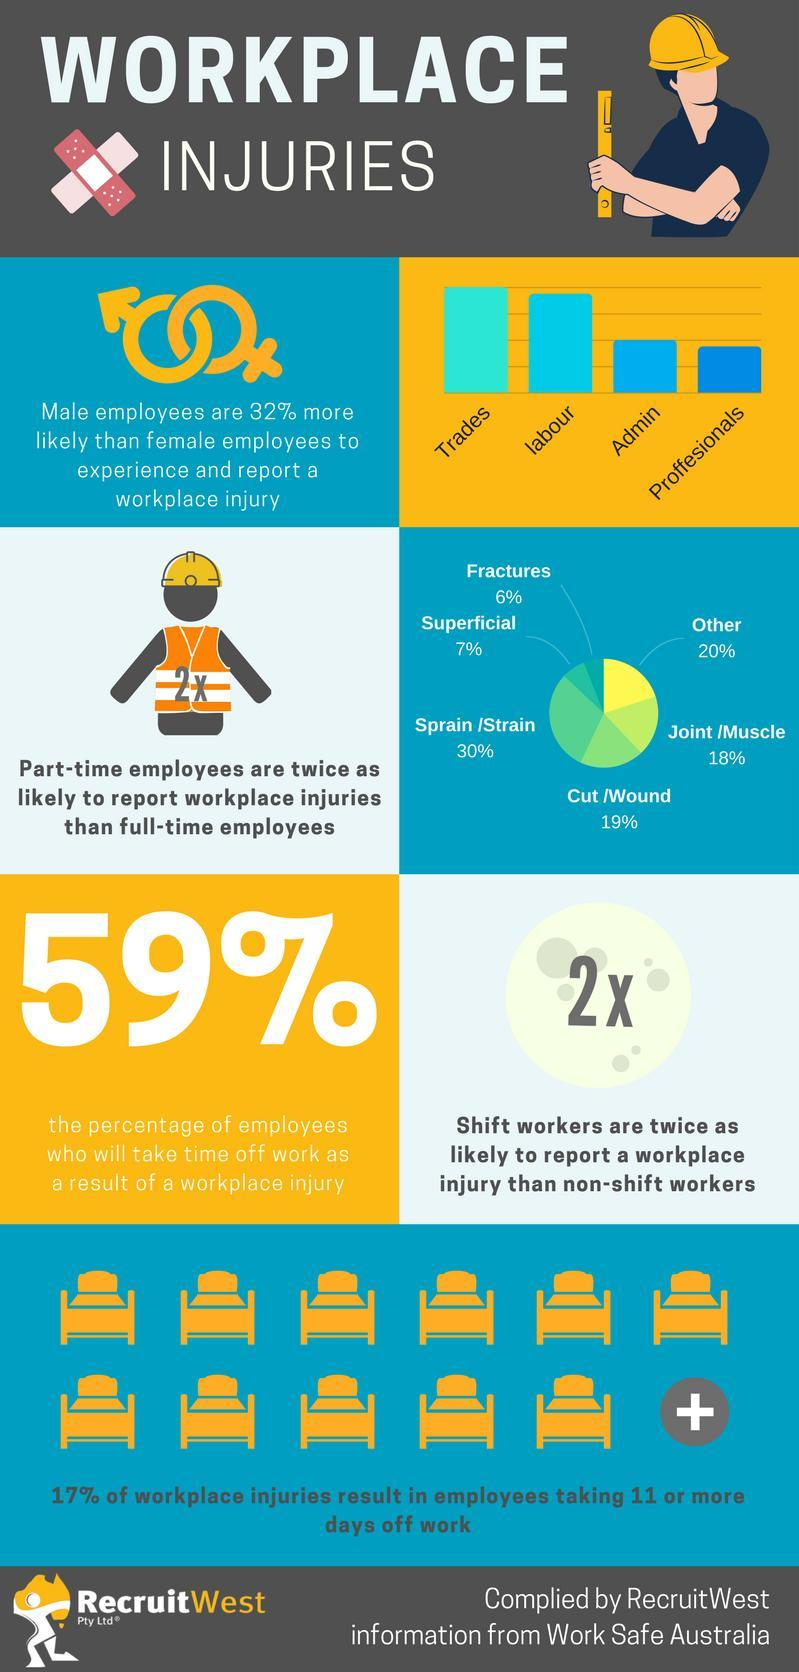What percentage of employees in Australia do not take time off from the work as as result of workplace injury?
Answer the question with a short phrase. 41% Which industry reports higher work-related injuries in Australia? Trades What percentage of part-time employees in Australia reported fractures? 6% What percentage of part-time employees in Australia reported superficial injuries? 7% Which industry reports fewer work-related injuries in Australia? Professionals 